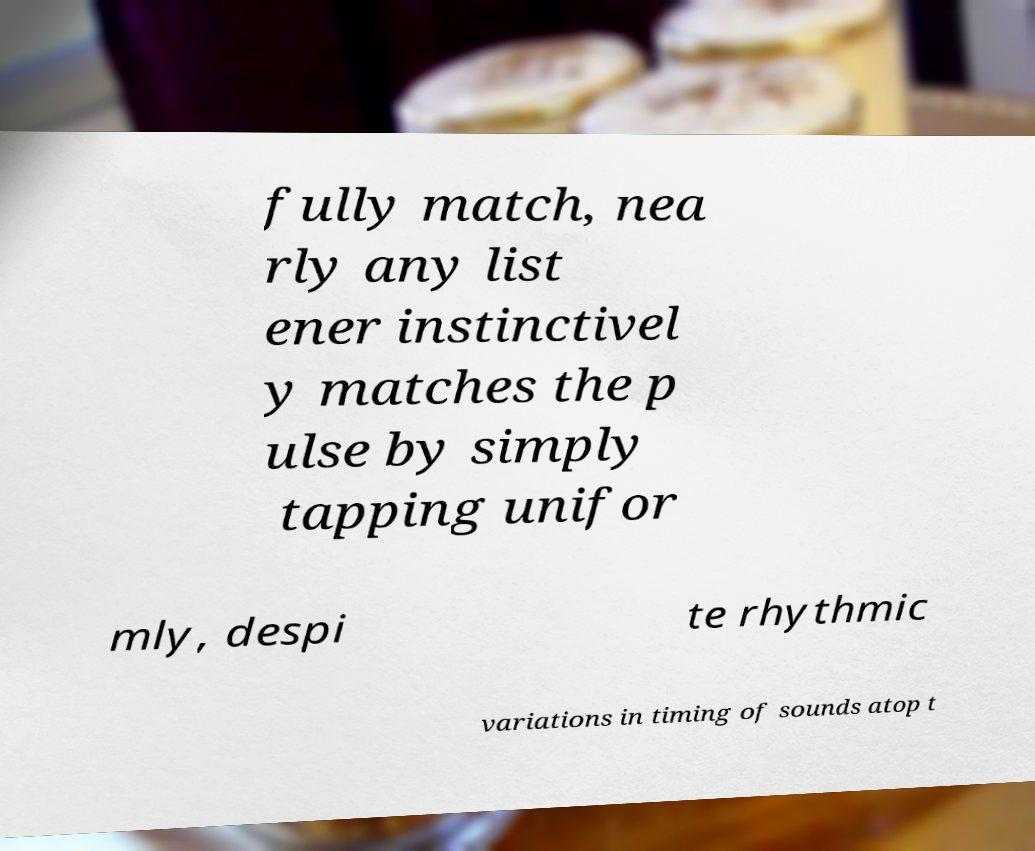I need the written content from this picture converted into text. Can you do that? fully match, nea rly any list ener instinctivel y matches the p ulse by simply tapping unifor mly, despi te rhythmic variations in timing of sounds atop t 